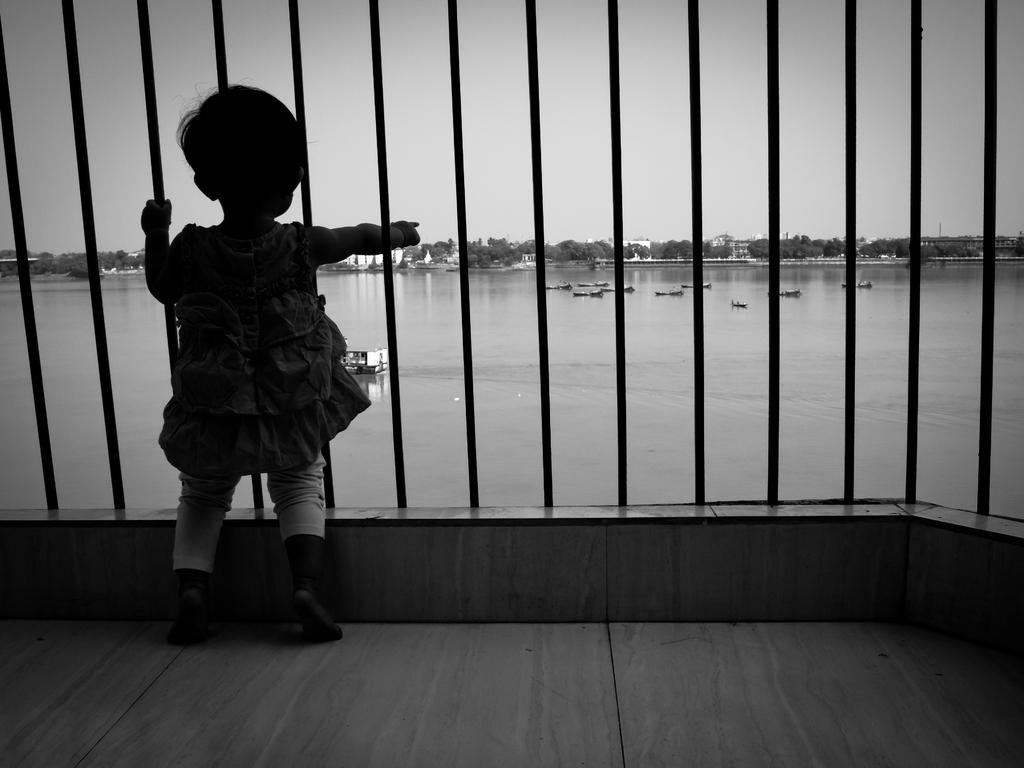What is the main subject in the foreground of the image? There is a kid standing near the fence in the foreground. What can be seen in the background of the image? Boats, trees, houses, and the sky are visible in the background. What might be the location of the image? The image may have been taken near a lake, as suggested by the presence of boats and water. What type of account does the kid need to access the boats in the image? There is no mention of any account or access requirement in the image; the kid is simply standing near the fence. 